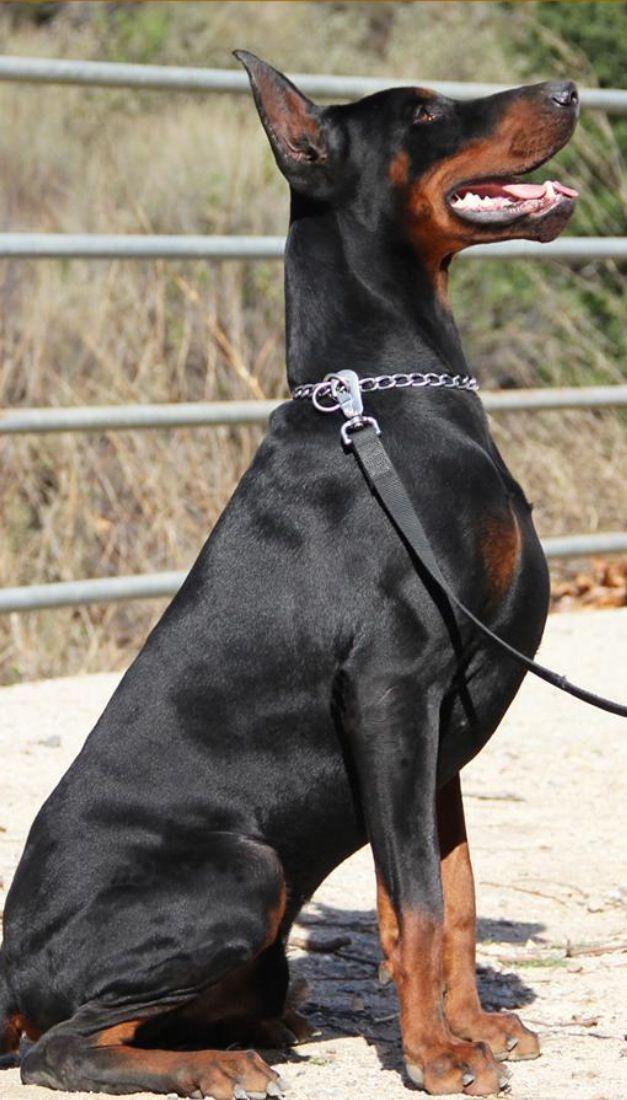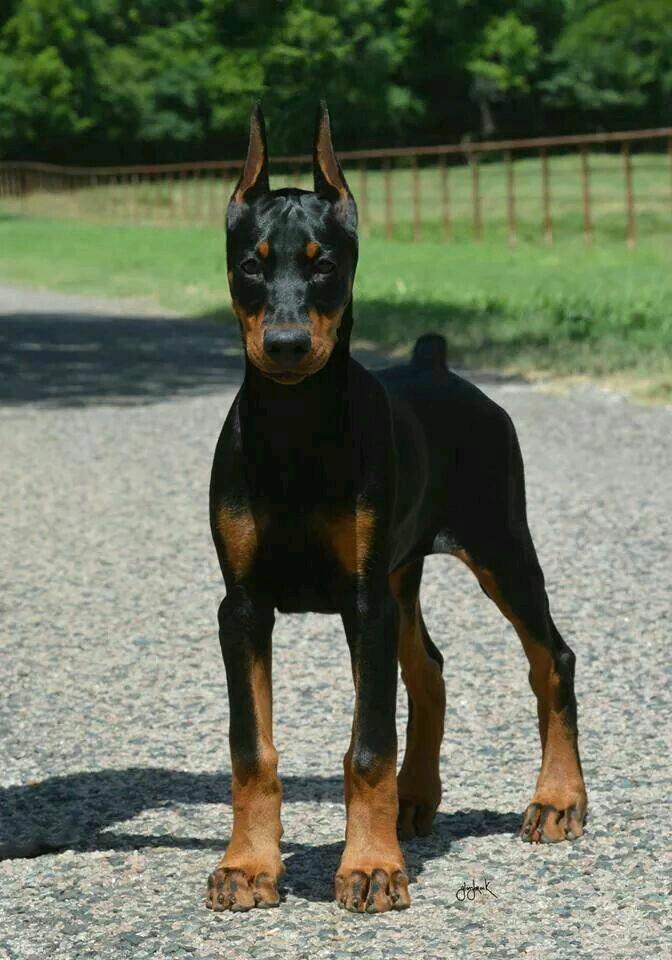The first image is the image on the left, the second image is the image on the right. For the images displayed, is the sentence "The left image features a doberman in a collar with its head in profile facing right, and the right image features a dock-tailed doberman standing on all fours with body angled leftward." factually correct? Answer yes or no. Yes. The first image is the image on the left, the second image is the image on the right. For the images displayed, is the sentence "The left image shows a black and brown dog with its mouth open and teeth visible." factually correct? Answer yes or no. Yes. 